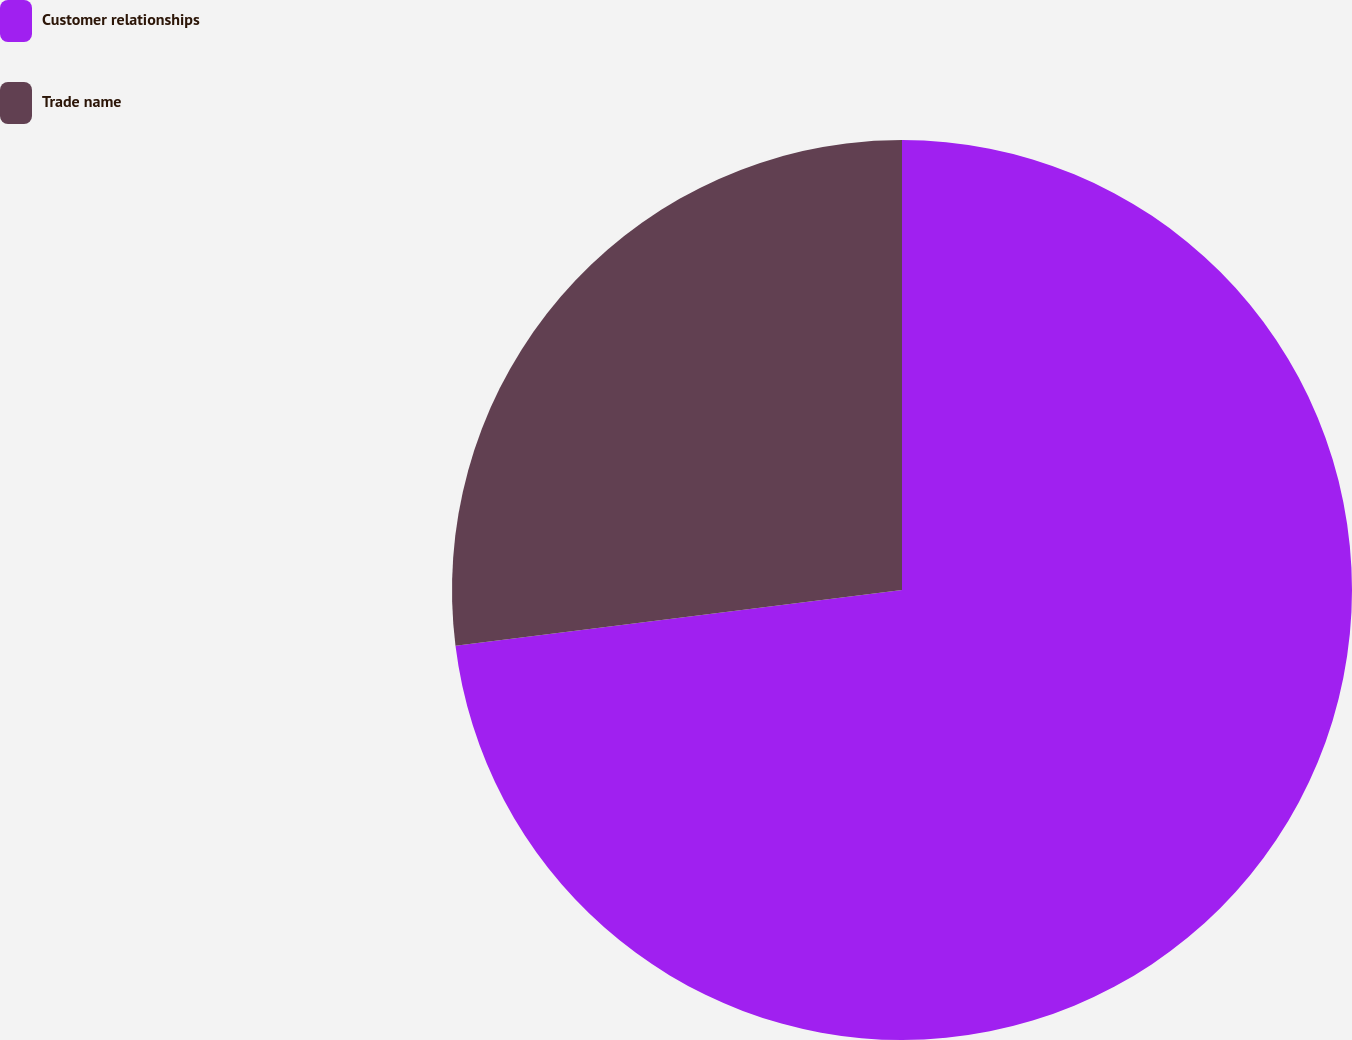Convert chart to OTSL. <chart><loc_0><loc_0><loc_500><loc_500><pie_chart><fcel>Customer relationships<fcel>Trade name<nl><fcel>73.02%<fcel>26.98%<nl></chart> 